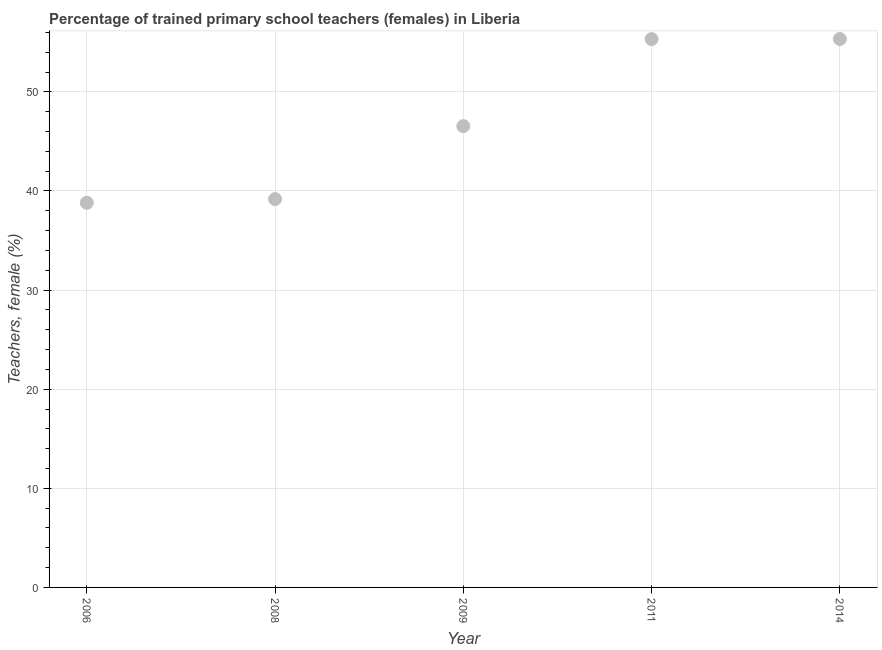What is the percentage of trained female teachers in 2009?
Keep it short and to the point. 46.54. Across all years, what is the maximum percentage of trained female teachers?
Offer a very short reply. 55.33. Across all years, what is the minimum percentage of trained female teachers?
Give a very brief answer. 38.81. In which year was the percentage of trained female teachers maximum?
Give a very brief answer. 2014. What is the sum of the percentage of trained female teachers?
Give a very brief answer. 235.19. What is the difference between the percentage of trained female teachers in 2008 and 2009?
Offer a very short reply. -7.37. What is the average percentage of trained female teachers per year?
Your answer should be compact. 47.04. What is the median percentage of trained female teachers?
Offer a very short reply. 46.54. In how many years, is the percentage of trained female teachers greater than 36 %?
Provide a short and direct response. 5. Do a majority of the years between 2009 and 2008 (inclusive) have percentage of trained female teachers greater than 22 %?
Your response must be concise. No. What is the ratio of the percentage of trained female teachers in 2008 to that in 2009?
Offer a terse response. 0.84. Is the percentage of trained female teachers in 2011 less than that in 2014?
Ensure brevity in your answer.  Yes. Is the difference between the percentage of trained female teachers in 2006 and 2014 greater than the difference between any two years?
Provide a short and direct response. Yes. What is the difference between the highest and the second highest percentage of trained female teachers?
Make the answer very short. 0.01. What is the difference between the highest and the lowest percentage of trained female teachers?
Your answer should be compact. 16.52. Does the percentage of trained female teachers monotonically increase over the years?
Your response must be concise. Yes. How many dotlines are there?
Keep it short and to the point. 1. How many years are there in the graph?
Give a very brief answer. 5. What is the difference between two consecutive major ticks on the Y-axis?
Offer a terse response. 10. Does the graph contain grids?
Make the answer very short. Yes. What is the title of the graph?
Offer a terse response. Percentage of trained primary school teachers (females) in Liberia. What is the label or title of the X-axis?
Ensure brevity in your answer.  Year. What is the label or title of the Y-axis?
Provide a succinct answer. Teachers, female (%). What is the Teachers, female (%) in 2006?
Keep it short and to the point. 38.81. What is the Teachers, female (%) in 2008?
Your response must be concise. 39.18. What is the Teachers, female (%) in 2009?
Provide a succinct answer. 46.54. What is the Teachers, female (%) in 2011?
Provide a short and direct response. 55.32. What is the Teachers, female (%) in 2014?
Ensure brevity in your answer.  55.33. What is the difference between the Teachers, female (%) in 2006 and 2008?
Your response must be concise. -0.37. What is the difference between the Teachers, female (%) in 2006 and 2009?
Your response must be concise. -7.73. What is the difference between the Teachers, female (%) in 2006 and 2011?
Provide a succinct answer. -16.51. What is the difference between the Teachers, female (%) in 2006 and 2014?
Your answer should be compact. -16.52. What is the difference between the Teachers, female (%) in 2008 and 2009?
Provide a succinct answer. -7.37. What is the difference between the Teachers, female (%) in 2008 and 2011?
Your answer should be very brief. -16.14. What is the difference between the Teachers, female (%) in 2008 and 2014?
Your answer should be compact. -16.15. What is the difference between the Teachers, female (%) in 2009 and 2011?
Give a very brief answer. -8.78. What is the difference between the Teachers, female (%) in 2009 and 2014?
Your answer should be very brief. -8.79. What is the difference between the Teachers, female (%) in 2011 and 2014?
Your answer should be very brief. -0.01. What is the ratio of the Teachers, female (%) in 2006 to that in 2008?
Give a very brief answer. 0.99. What is the ratio of the Teachers, female (%) in 2006 to that in 2009?
Provide a succinct answer. 0.83. What is the ratio of the Teachers, female (%) in 2006 to that in 2011?
Your answer should be compact. 0.7. What is the ratio of the Teachers, female (%) in 2006 to that in 2014?
Offer a terse response. 0.7. What is the ratio of the Teachers, female (%) in 2008 to that in 2009?
Your answer should be very brief. 0.84. What is the ratio of the Teachers, female (%) in 2008 to that in 2011?
Your response must be concise. 0.71. What is the ratio of the Teachers, female (%) in 2008 to that in 2014?
Your answer should be compact. 0.71. What is the ratio of the Teachers, female (%) in 2009 to that in 2011?
Provide a succinct answer. 0.84. What is the ratio of the Teachers, female (%) in 2009 to that in 2014?
Your answer should be compact. 0.84. What is the ratio of the Teachers, female (%) in 2011 to that in 2014?
Make the answer very short. 1. 